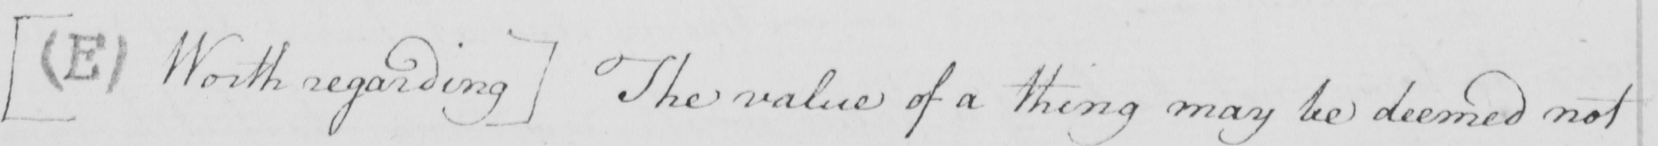Please transcribe the handwritten text in this image. [  ( E )  Worth regarding ]  The value of a thing may be deemed not 